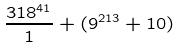<formula> <loc_0><loc_0><loc_500><loc_500>\frac { 3 1 8 ^ { 4 1 } } { 1 } + ( 9 ^ { 2 1 3 } + 1 0 )</formula> 